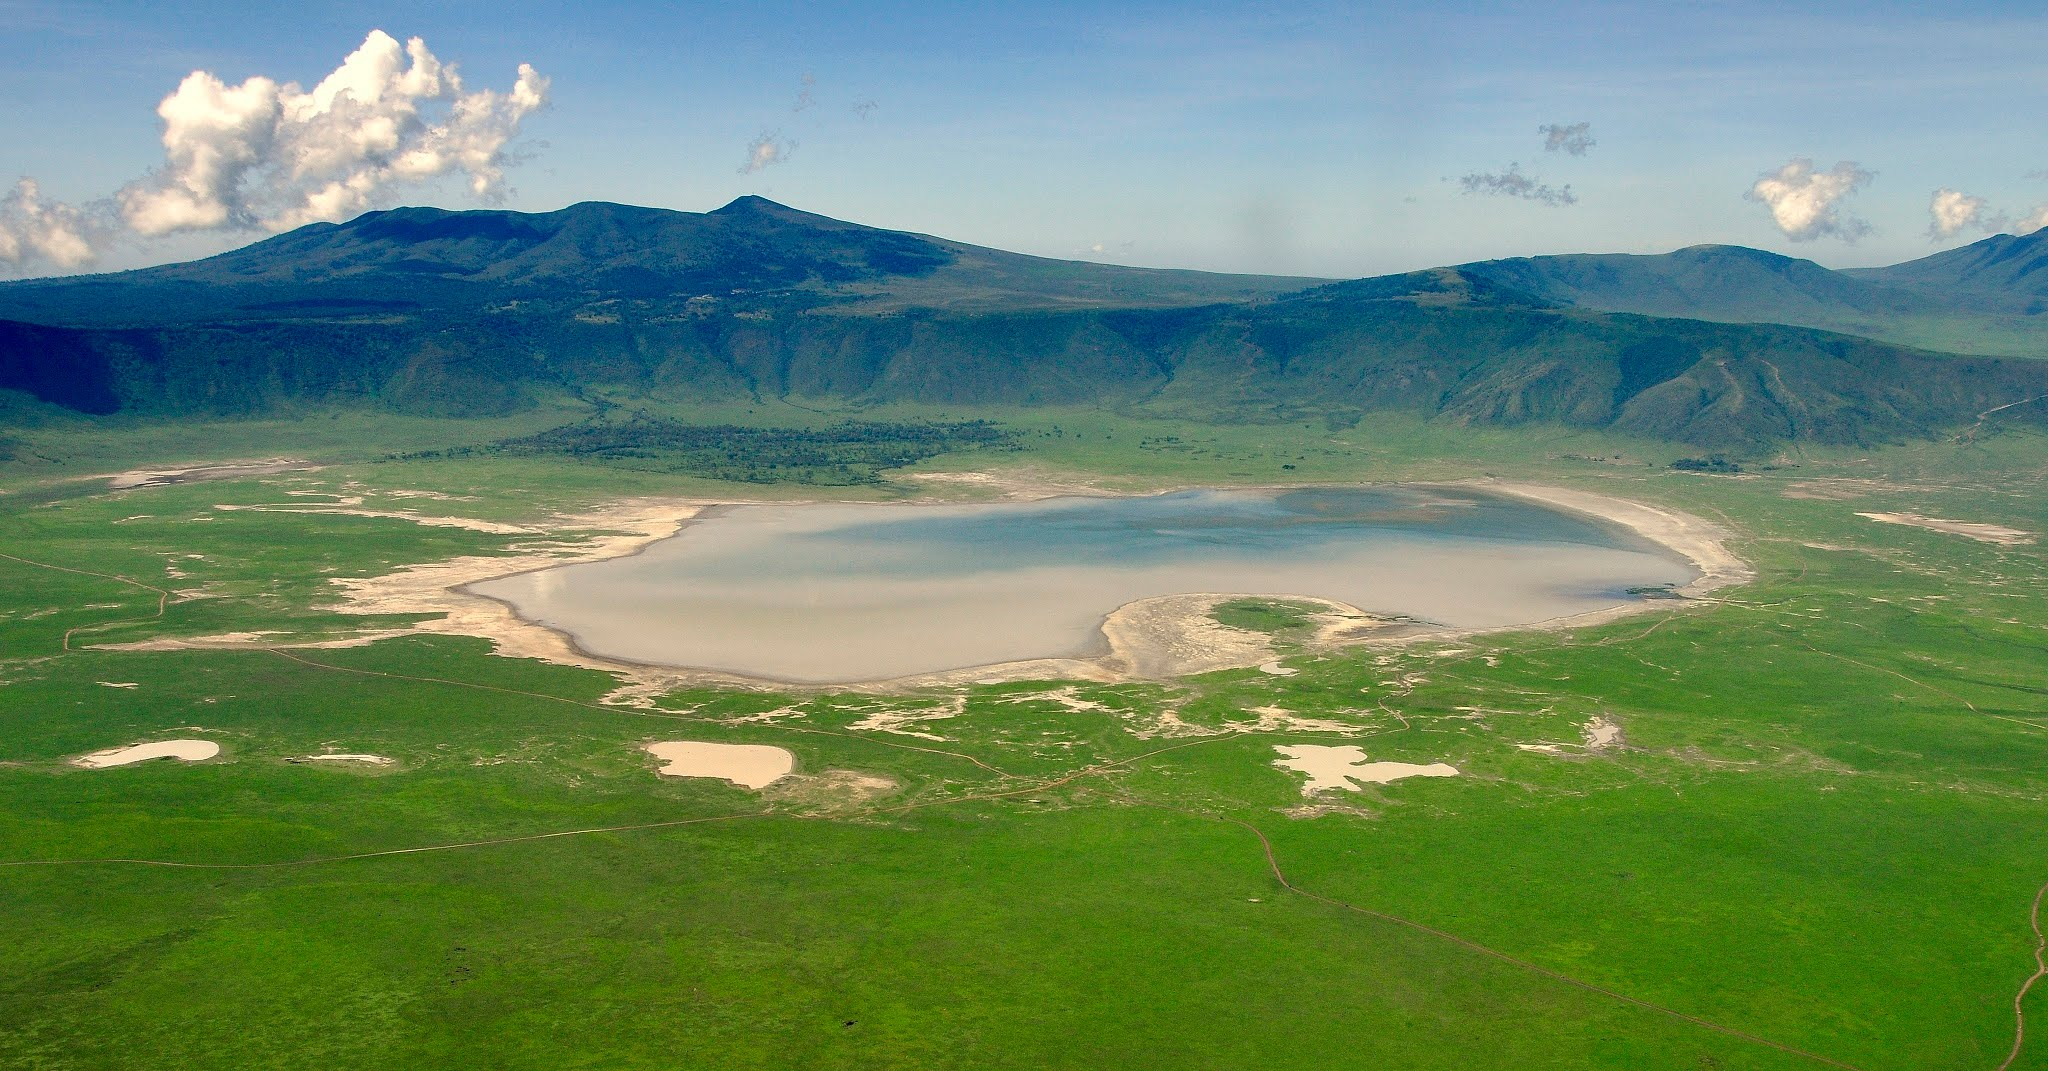Write a detailed description of the given image. The image shows a sweeping view of the Ngorongoro Crater in Tanzania, which is actually a UNESCO World Heritage site. Captured from an elevated perspective, the vast, grassy caldera floor is partially occupied by a seasonal shallow water body, with variations in water levels leading to variations in size and depth conspicuously throughout the year. Undulating hills surround the crater, suggesting its volcanic origin, while the crater's rim is cloaked with lush highland forest. Above, the sky, shifting from clear to partly cloudy, crowns the landscape, creating an interplay of shadows and light that highlights the crater’s natural diversity, including signs of wildlife and small streams from recent rains crisscrossing the crater floor. This natural amphitheater is home to a rich array of African wildlife, making it an invaluable conservation area and a pinnacle of the natural world. 